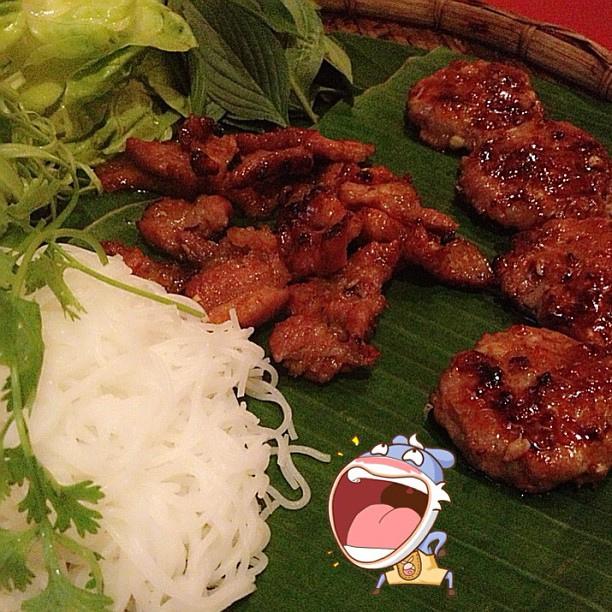Is this food on a tray?
Concise answer only. Yes. Does this look like American cuisine?
Write a very short answer. No. What is the cartoon character doing?
Concise answer only. Yelling. 